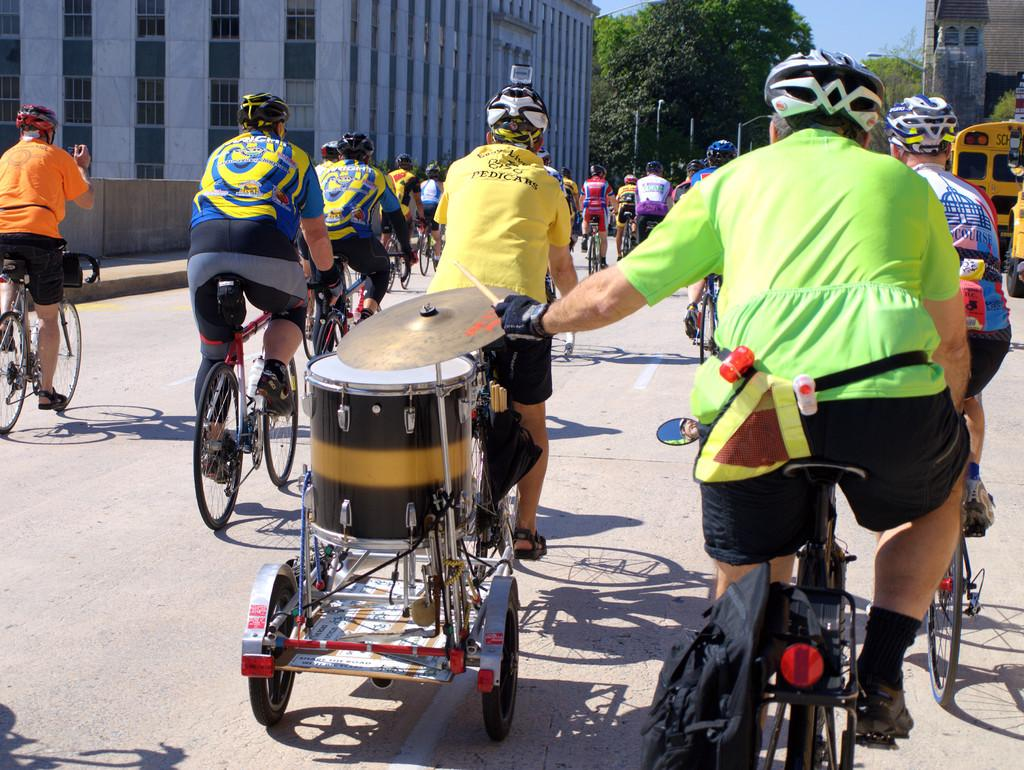What are the people in the image doing? The people in the image are cycling on the road. Can you describe the man on the right side of the image? The man on the right side of the image is holding an object in his hand. What type of natural elements can be seen in the image? There are trees visible in the image. What type of structures can be seen in the image? There is at least one building in the image. How many wings does the dog have in the image? There is no dog present in the image, and therefore no wings can be observed. What is the size of the object the man is holding in the image? The size of the object the man is holding cannot be determined from the image alone. 